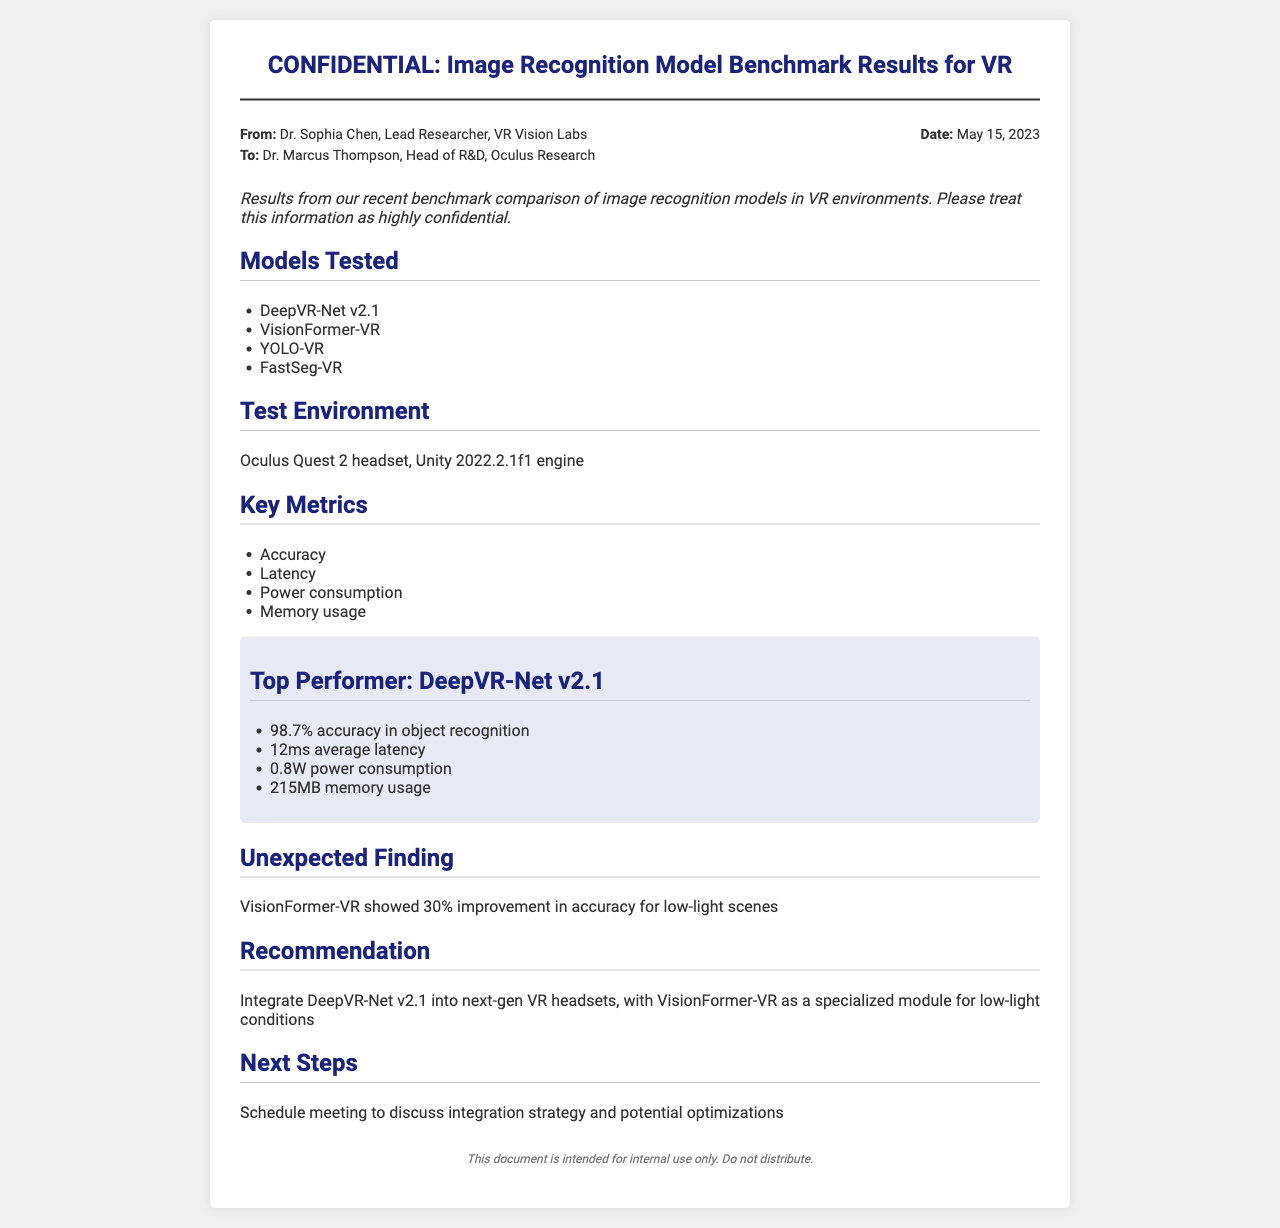what is the date of the document? The date is explicitly stated in the document as May 15, 2023.
Answer: May 15, 2023 who is the lead researcher mentioned? The lead researcher is named as Dr. Sophia Chen in the document.
Answer: Dr. Sophia Chen which model achieved the highest accuracy? The document highlights that DeepVR-Net v2.1 is the top performer with accuracy.
Answer: DeepVR-Net v2.1 what was the accuracy percentage of DeepVR-Net v2.1? The document specifies that DeepVR-Net v2.1 achieved an accuracy of 98.7%.
Answer: 98.7% what is a recommendation made in the document? The document recommends integrating DeepVR-Net v2.1 into next-gen VR headsets.
Answer: Integrate DeepVR-Net v2.1 what unique finding is noted regarding VisionFormer-VR? The document notes that VisionFormer-VR showed a 30% improvement in accuracy for low-light scenes.
Answer: 30% improvement how much power does DeepVR-Net v2.1 consume? The power consumption stated in the document for DeepVR-Net v2.1 is given clearly.
Answer: 0.8W what is the total memory usage of DeepVR-Net v2.1? According to the document, DeepVR-Net v2.1 uses 215MB of memory.
Answer: 215MB what is the purpose of this document? The document is intended for internal use only and emphasizes confidentiality.
Answer: Internal use only 